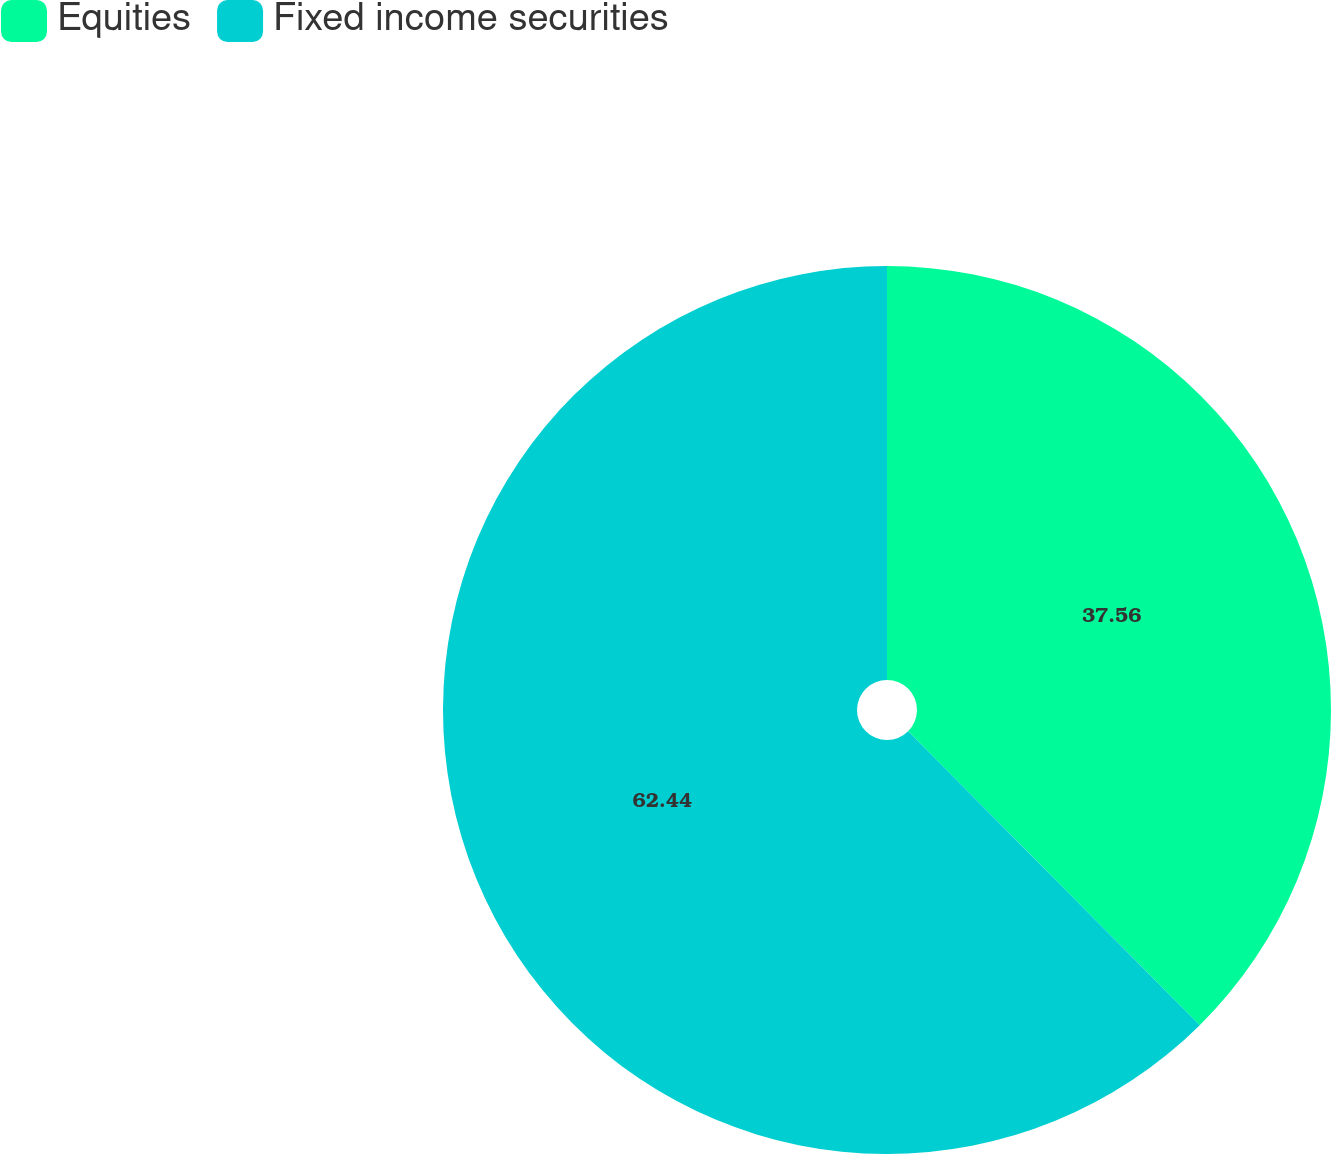<chart> <loc_0><loc_0><loc_500><loc_500><pie_chart><fcel>Equities<fcel>Fixed income securities<nl><fcel>37.56%<fcel>62.44%<nl></chart> 